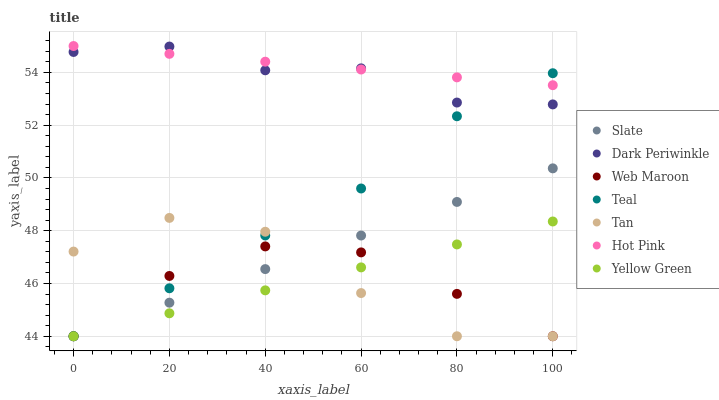Does Web Maroon have the minimum area under the curve?
Answer yes or no. Yes. Does Hot Pink have the maximum area under the curve?
Answer yes or no. Yes. Does Slate have the minimum area under the curve?
Answer yes or no. No. Does Slate have the maximum area under the curve?
Answer yes or no. No. Is Slate the smoothest?
Answer yes or no. Yes. Is Tan the roughest?
Answer yes or no. Yes. Is Hot Pink the smoothest?
Answer yes or no. No. Is Hot Pink the roughest?
Answer yes or no. No. Does Yellow Green have the lowest value?
Answer yes or no. Yes. Does Hot Pink have the lowest value?
Answer yes or no. No. Does Hot Pink have the highest value?
Answer yes or no. Yes. Does Slate have the highest value?
Answer yes or no. No. Is Web Maroon less than Hot Pink?
Answer yes or no. Yes. Is Dark Periwinkle greater than Tan?
Answer yes or no. Yes. Does Hot Pink intersect Dark Periwinkle?
Answer yes or no. Yes. Is Hot Pink less than Dark Periwinkle?
Answer yes or no. No. Is Hot Pink greater than Dark Periwinkle?
Answer yes or no. No. Does Web Maroon intersect Hot Pink?
Answer yes or no. No. 